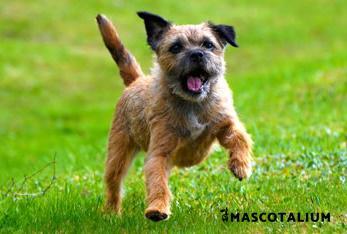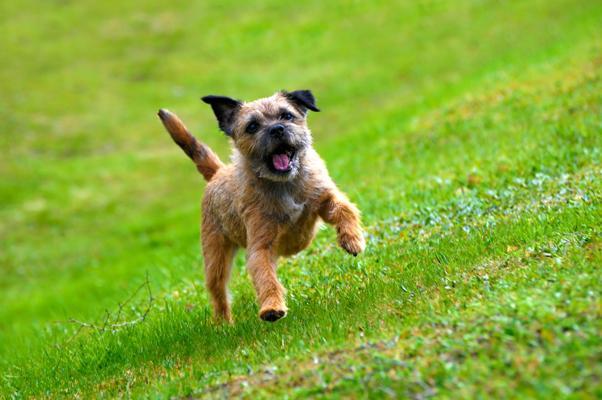The first image is the image on the left, the second image is the image on the right. Analyze the images presented: Is the assertion "A dog has a front paw off the ground." valid? Answer yes or no. Yes. The first image is the image on the left, the second image is the image on the right. For the images shown, is this caption "The left image features one dog in a sitting pose, and the right image shows a dog gazing at the camera and standing up on at least three feet." true? Answer yes or no. No. 